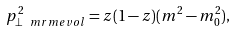Convert formula to latex. <formula><loc_0><loc_0><loc_500><loc_500>p _ { \perp \ m r m { e v o l } } ^ { 2 } = z ( 1 - z ) ( m ^ { 2 } - m _ { 0 } ^ { 2 } ) ,</formula> 